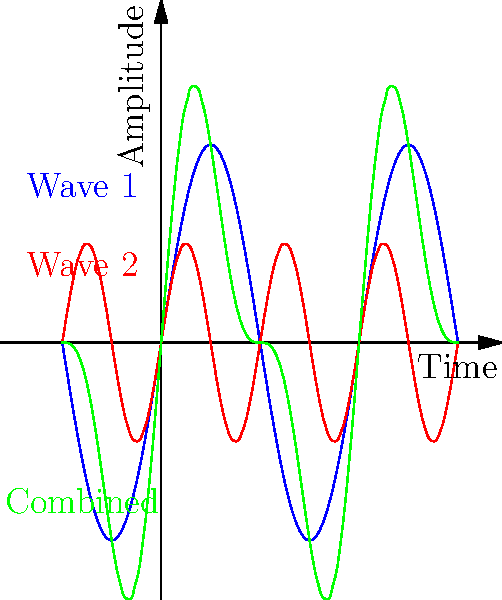As a DJ, you're experimenting with mixing two sound waves in the club. The blue wave represents a bass line at frequency $f$, and the red wave represents a synth at frequency $2f$. What phenomenon does the resulting green wave demonstrate, and how might this affect the overall sound in the club? To understand this phenomenon, let's break it down step-by-step:

1. Wave representation:
   - Blue wave: Bass line with frequency $f$
   - Red wave: Synth with frequency $2f$ (double the bass frequency)
   - Green wave: Combined result of the blue and red waves

2. Wave characteristics:
   - The blue wave has a larger amplitude and lower frequency.
   - The red wave has a smaller amplitude and higher frequency.

3. Interference pattern:
   - The green wave shows the result of superposition of the two waves.
   - At some points, the waves reinforce each other (constructive interference).
   - At other points, they partially cancel each other (destructive interference).

4. Resulting phenomenon:
   - This combination creates a complex waveform known as a "beat" pattern.
   - The beat frequency is the difference between the two original frequencies.

5. Effect on club sound:
   - The listeners will hear a pulsating effect in the overall sound.
   - The beat pattern creates a rhythmic emphasis that can enhance the music's groove.
   - This technique is often used in electronic dance music to create interesting textures and rhythms.

6. DJ application:
   - As a DJ, you can use this phenomenon to create dynamic mixes and transitions.
   - By carefully selecting and combining frequencies, you can produce engaging sound effects that energize the dance floor.
Answer: Beat phenomenon 